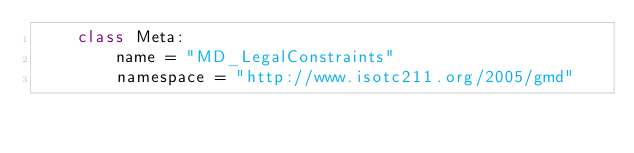<code> <loc_0><loc_0><loc_500><loc_500><_Python_>    class Meta:
        name = "MD_LegalConstraints"
        namespace = "http://www.isotc211.org/2005/gmd"
</code> 